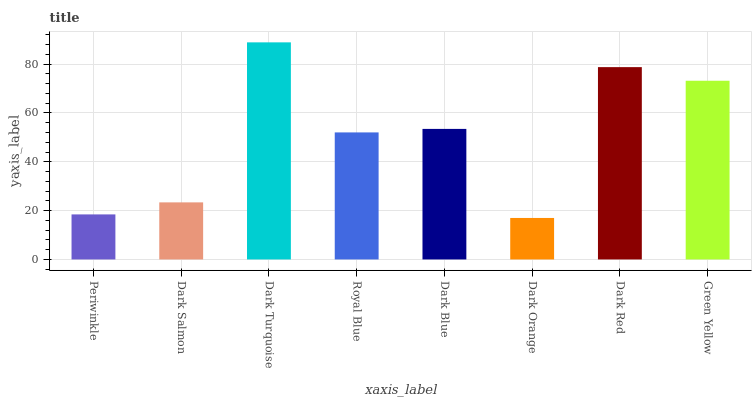Is Dark Salmon the minimum?
Answer yes or no. No. Is Dark Salmon the maximum?
Answer yes or no. No. Is Dark Salmon greater than Periwinkle?
Answer yes or no. Yes. Is Periwinkle less than Dark Salmon?
Answer yes or no. Yes. Is Periwinkle greater than Dark Salmon?
Answer yes or no. No. Is Dark Salmon less than Periwinkle?
Answer yes or no. No. Is Dark Blue the high median?
Answer yes or no. Yes. Is Royal Blue the low median?
Answer yes or no. Yes. Is Dark Red the high median?
Answer yes or no. No. Is Dark Orange the low median?
Answer yes or no. No. 